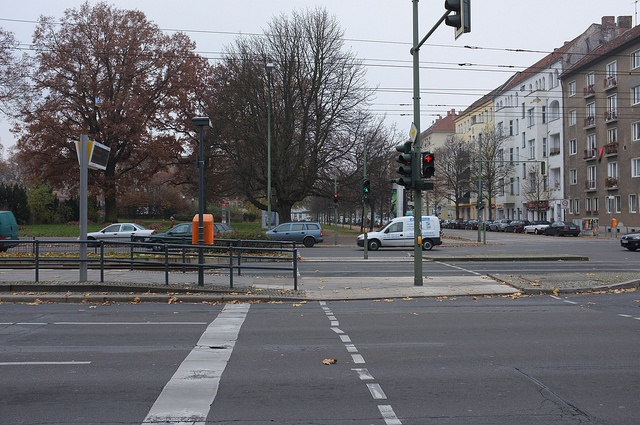Describe the objects in this image and their specific colors. I can see truck in lavender, black, gray, and darkgray tones, car in lavender, black, and gray tones, car in lavender, black, gray, and blue tones, traffic light in lavender, black, gray, and purple tones, and car in lavender, gray, and darkgray tones in this image. 